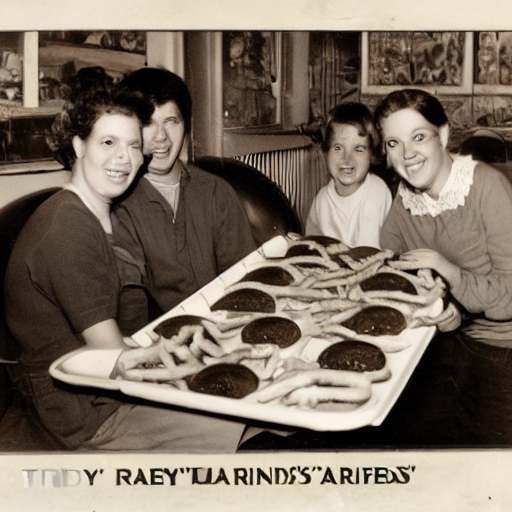Can you guess what the occasion might be? Given the shared delight and the oversized tray of food, it's plausible the occasion might be a special promotion at a diner, a celebration of a milestone, or perhaps a competitive eating event. The setting appears to be casual and social, typical of a fun gathering. 